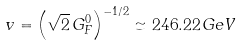<formula> <loc_0><loc_0><loc_500><loc_500>v = \left ( { \sqrt { 2 } } \, G _ { F } ^ { 0 } \right ) ^ { - 1 / 2 } \simeq 2 4 6 . 2 2 \, { G e V }</formula> 